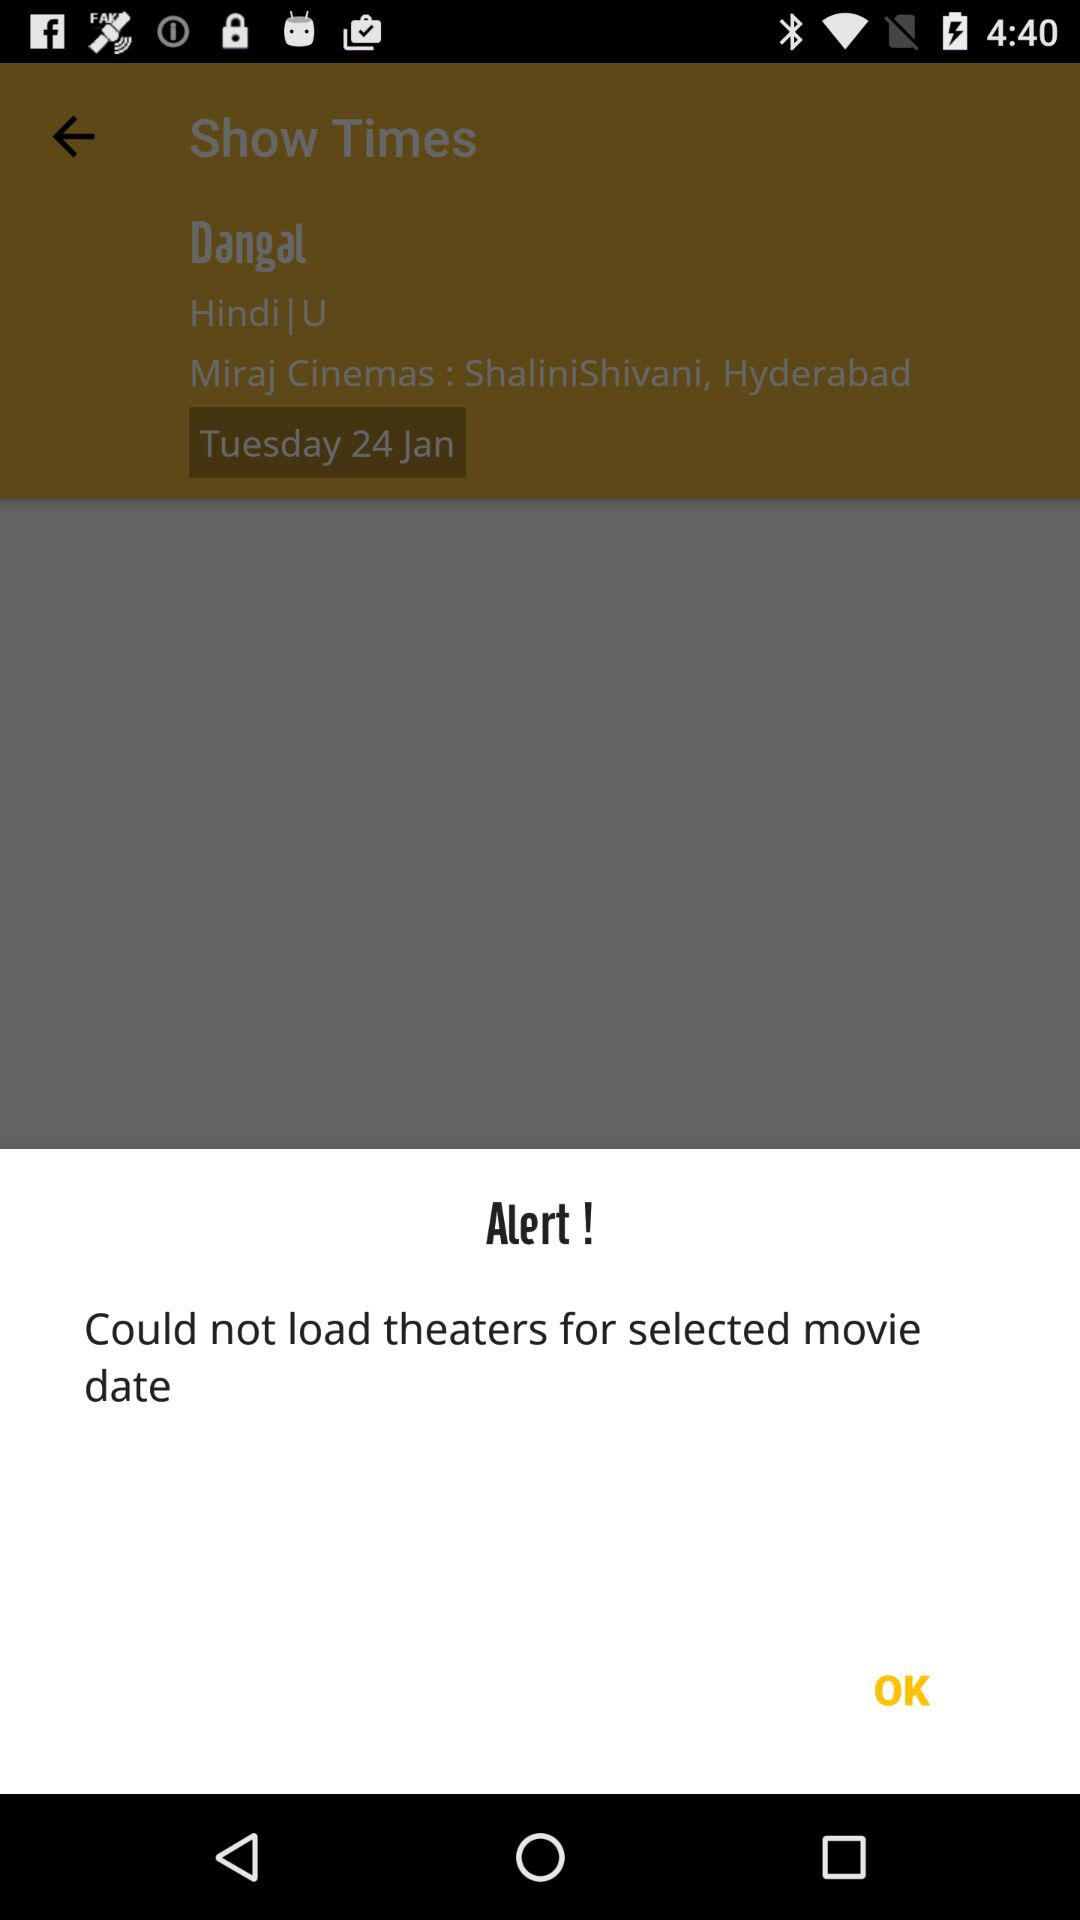What is the location of the cinema? The location is Miraj Cinemas: ShaliniShivani, Hyderabad. 